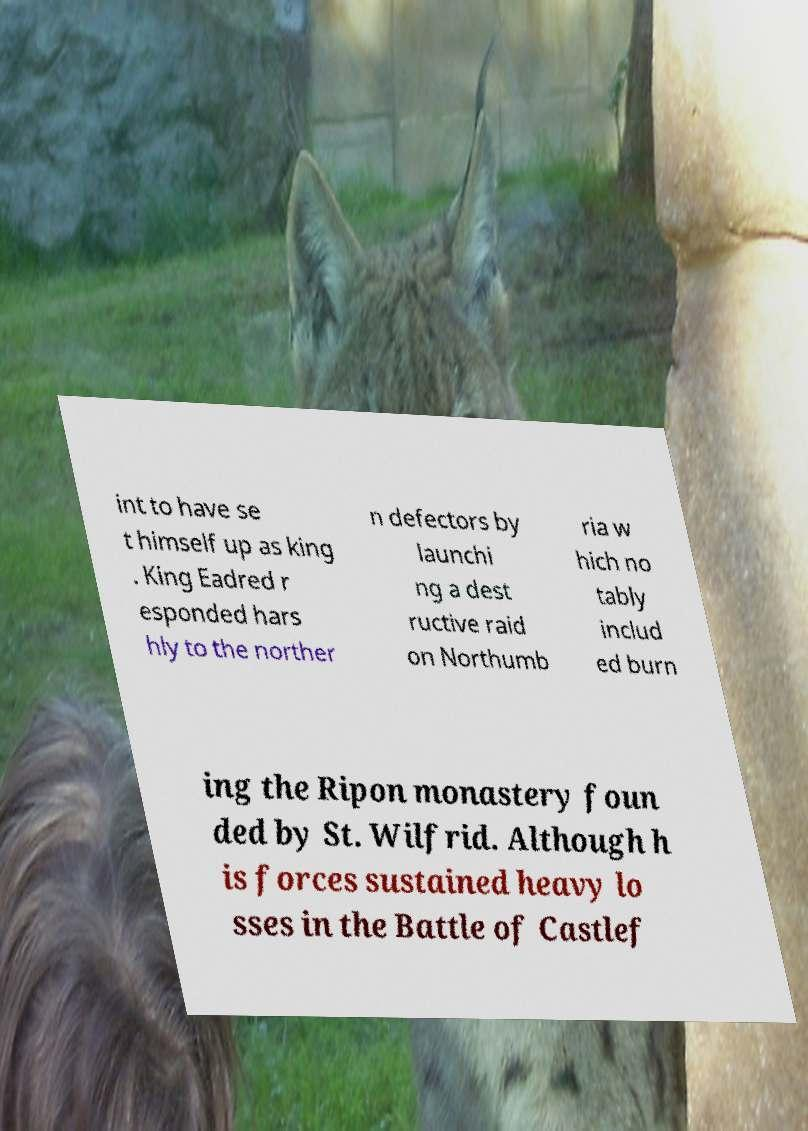Can you read and provide the text displayed in the image?This photo seems to have some interesting text. Can you extract and type it out for me? int to have se t himself up as king . King Eadred r esponded hars hly to the norther n defectors by launchi ng a dest ructive raid on Northumb ria w hich no tably includ ed burn ing the Ripon monastery foun ded by St. Wilfrid. Although h is forces sustained heavy lo sses in the Battle of Castlef 